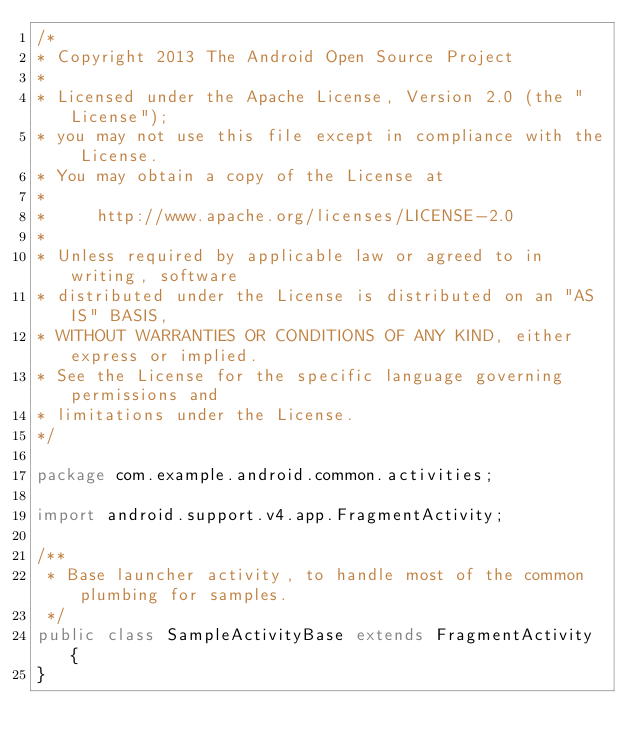Convert code to text. <code><loc_0><loc_0><loc_500><loc_500><_Java_>/*
* Copyright 2013 The Android Open Source Project
*
* Licensed under the Apache License, Version 2.0 (the "License");
* you may not use this file except in compliance with the License.
* You may obtain a copy of the License at
*
*     http://www.apache.org/licenses/LICENSE-2.0
*
* Unless required by applicable law or agreed to in writing, software
* distributed under the License is distributed on an "AS IS" BASIS,
* WITHOUT WARRANTIES OR CONDITIONS OF ANY KIND, either express or implied.
* See the License for the specific language governing permissions and
* limitations under the License.
*/

package com.example.android.common.activities;

import android.support.v4.app.FragmentActivity;

/**
 * Base launcher activity, to handle most of the common plumbing for samples.
 */
public class SampleActivityBase extends FragmentActivity {
}</code> 